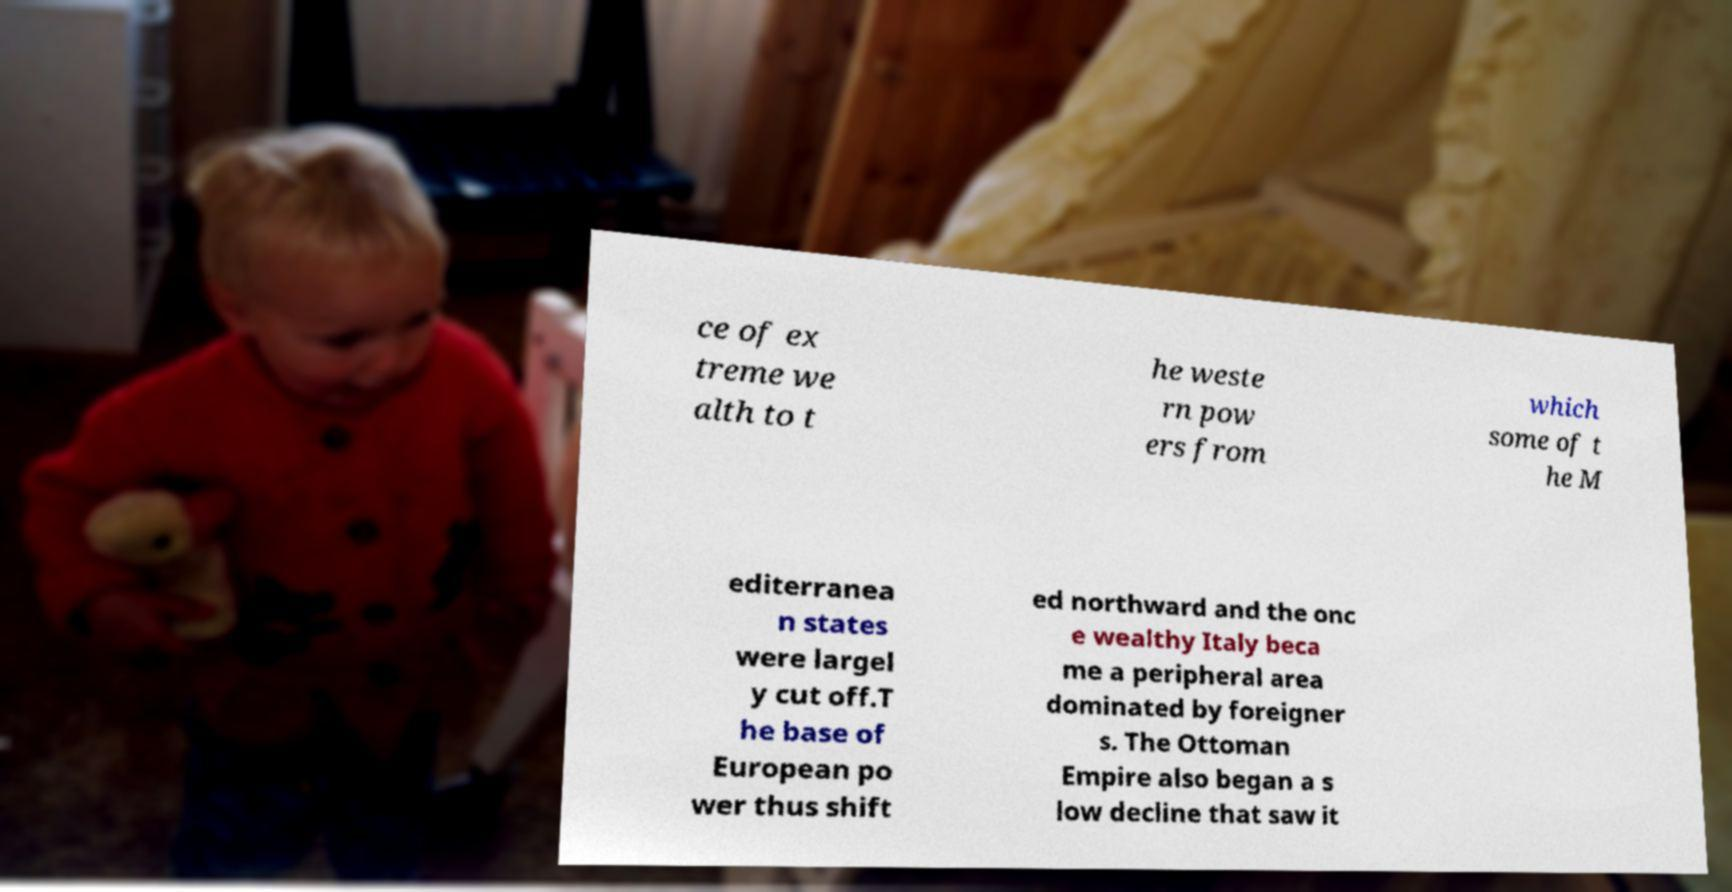Could you extract and type out the text from this image? ce of ex treme we alth to t he weste rn pow ers from which some of t he M editerranea n states were largel y cut off.T he base of European po wer thus shift ed northward and the onc e wealthy Italy beca me a peripheral area dominated by foreigner s. The Ottoman Empire also began a s low decline that saw it 